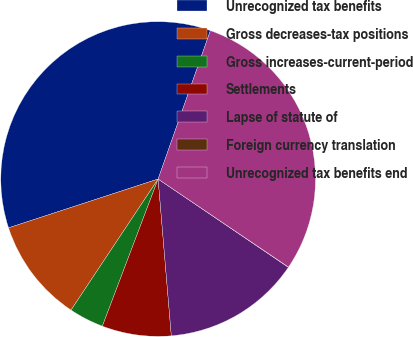Convert chart to OTSL. <chart><loc_0><loc_0><loc_500><loc_500><pie_chart><fcel>Unrecognized tax benefits<fcel>Gross decreases-tax positions<fcel>Gross increases-current-period<fcel>Settlements<fcel>Lapse of statute of<fcel>Foreign currency translation<fcel>Unrecognized tax benefits end<nl><fcel>35.41%<fcel>10.64%<fcel>3.57%<fcel>7.1%<fcel>14.18%<fcel>0.03%<fcel>29.06%<nl></chart> 